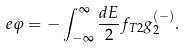Convert formula to latex. <formula><loc_0><loc_0><loc_500><loc_500>e \varphi = - \int _ { - \infty } ^ { \infty } \frac { d E } { 2 } f _ { T 2 } g ^ { ( - ) } _ { 2 } .</formula> 